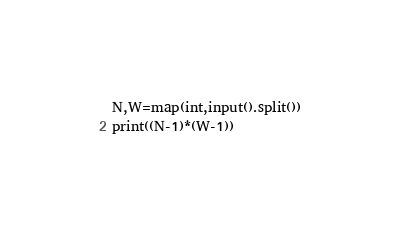Convert code to text. <code><loc_0><loc_0><loc_500><loc_500><_Python_>N,W=map(int,input().split())
print((N-1)*(W-1))</code> 